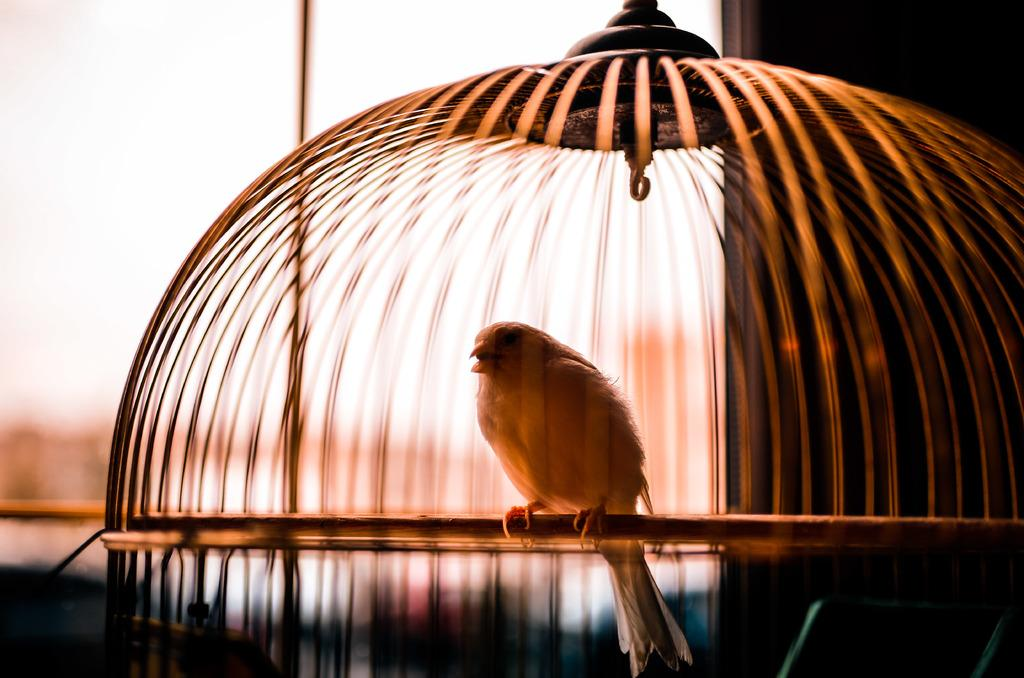What type of animal is present in the image? There is a bird in the image. What is the bird's current situation? The bird is inside a net. Can you describe the color of the net? The net is brown in color. How would you describe the background of the image? The background of the image is blurred. Is the queen sitting on a throne in the image? There is no queen or throne present in the image; it features a bird inside a brown net. Can you see an airplane flying in the background of the image? There is no airplane visible in the image; the background is blurred. 